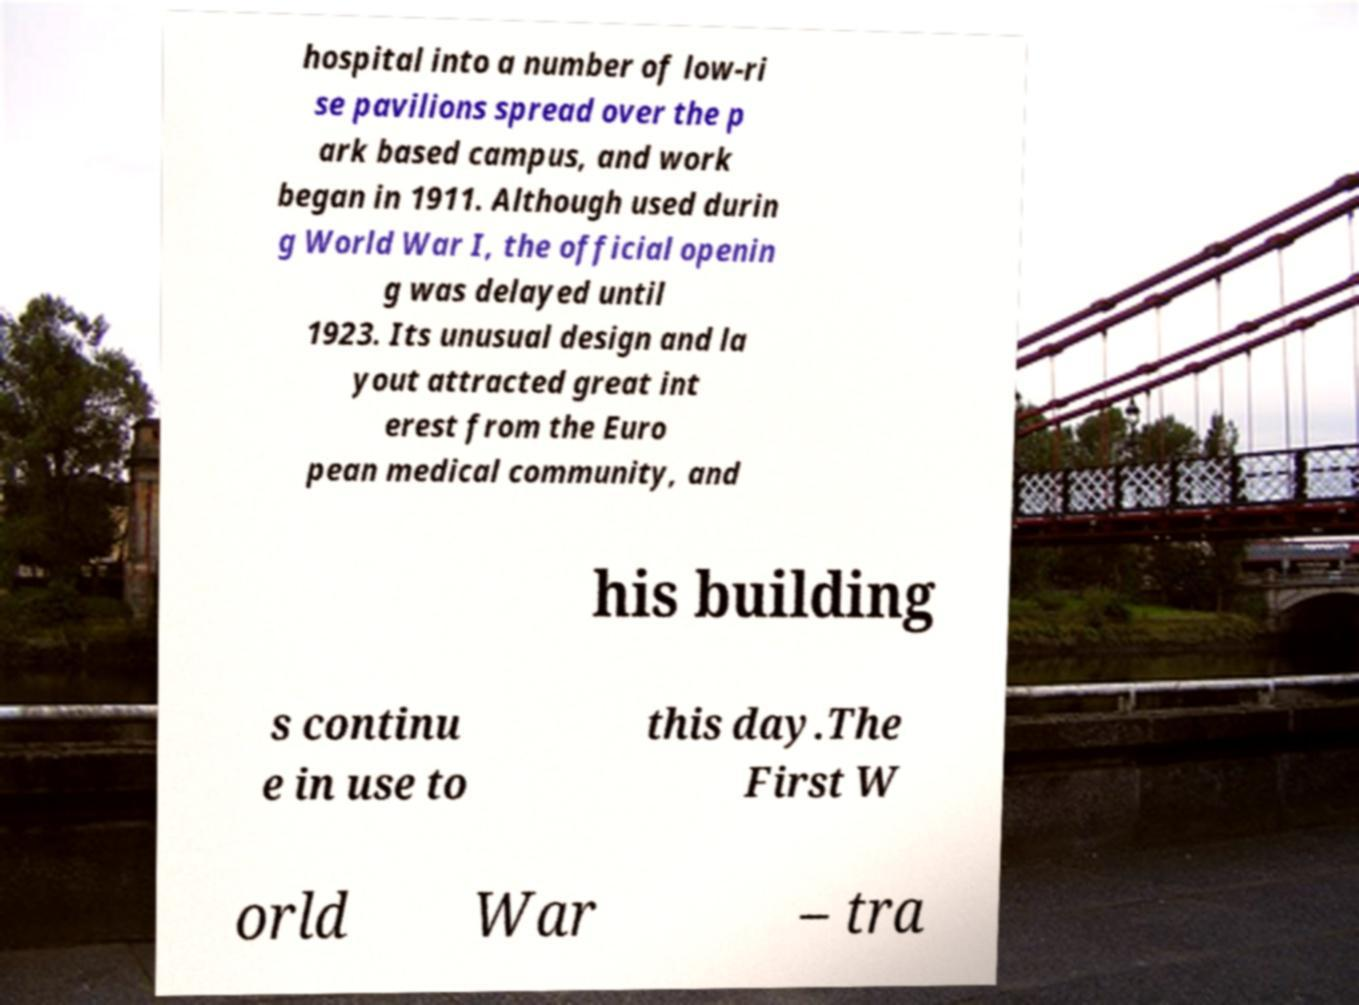What messages or text are displayed in this image? I need them in a readable, typed format. hospital into a number of low-ri se pavilions spread over the p ark based campus, and work began in 1911. Although used durin g World War I, the official openin g was delayed until 1923. Its unusual design and la yout attracted great int erest from the Euro pean medical community, and his building s continu e in use to this day.The First W orld War – tra 